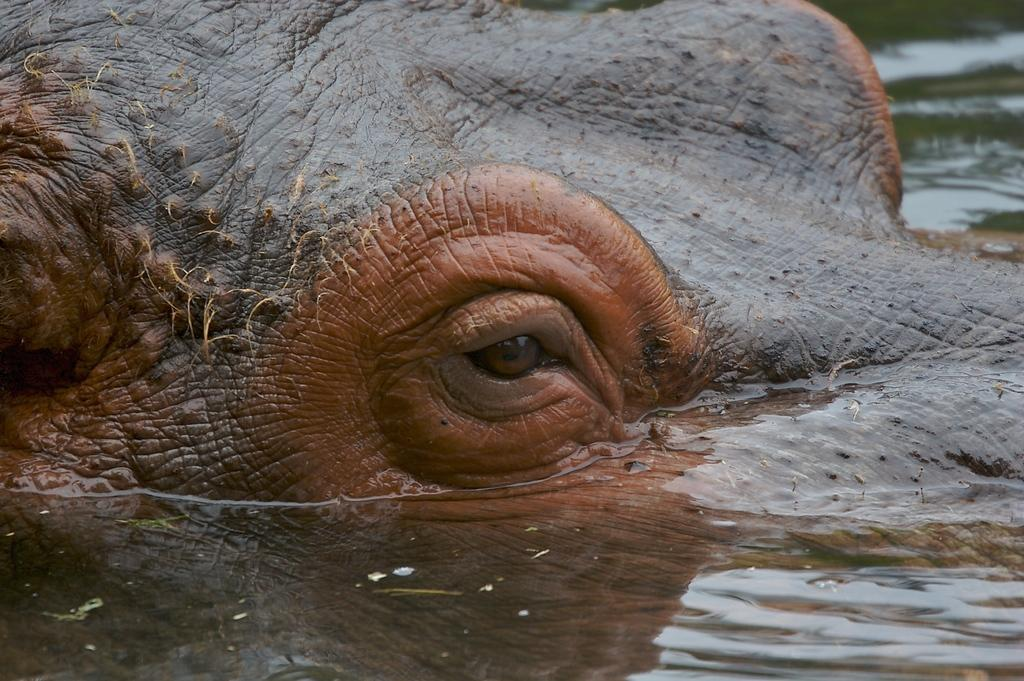What is the main subject of the image? There is an animal in the water. Can you describe a specific feature of the animal? The animal's eye is visible in the middle of the image. What type of knot is the writer using to tie the dolls together in the image? There is no writer or dolls present in the image; it features an animal in the water with its eye visible. 